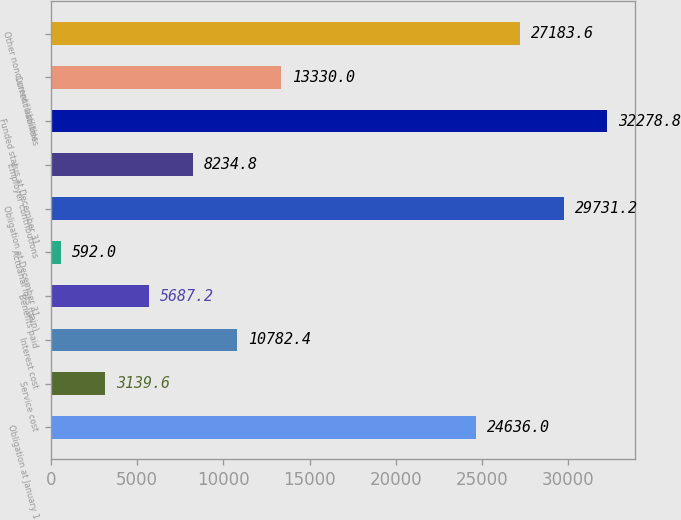Convert chart. <chart><loc_0><loc_0><loc_500><loc_500><bar_chart><fcel>Obligation at January 1<fcel>Service cost<fcel>Interest cost<fcel>Benefits paid<fcel>Actuarial loss (gain)<fcel>Obligation at December 31<fcel>Employer contributions<fcel>Funded status at December 31<fcel>Current liabilities<fcel>Other noncurrent liabilities<nl><fcel>24636<fcel>3139.6<fcel>10782.4<fcel>5687.2<fcel>592<fcel>29731.2<fcel>8234.8<fcel>32278.8<fcel>13330<fcel>27183.6<nl></chart> 